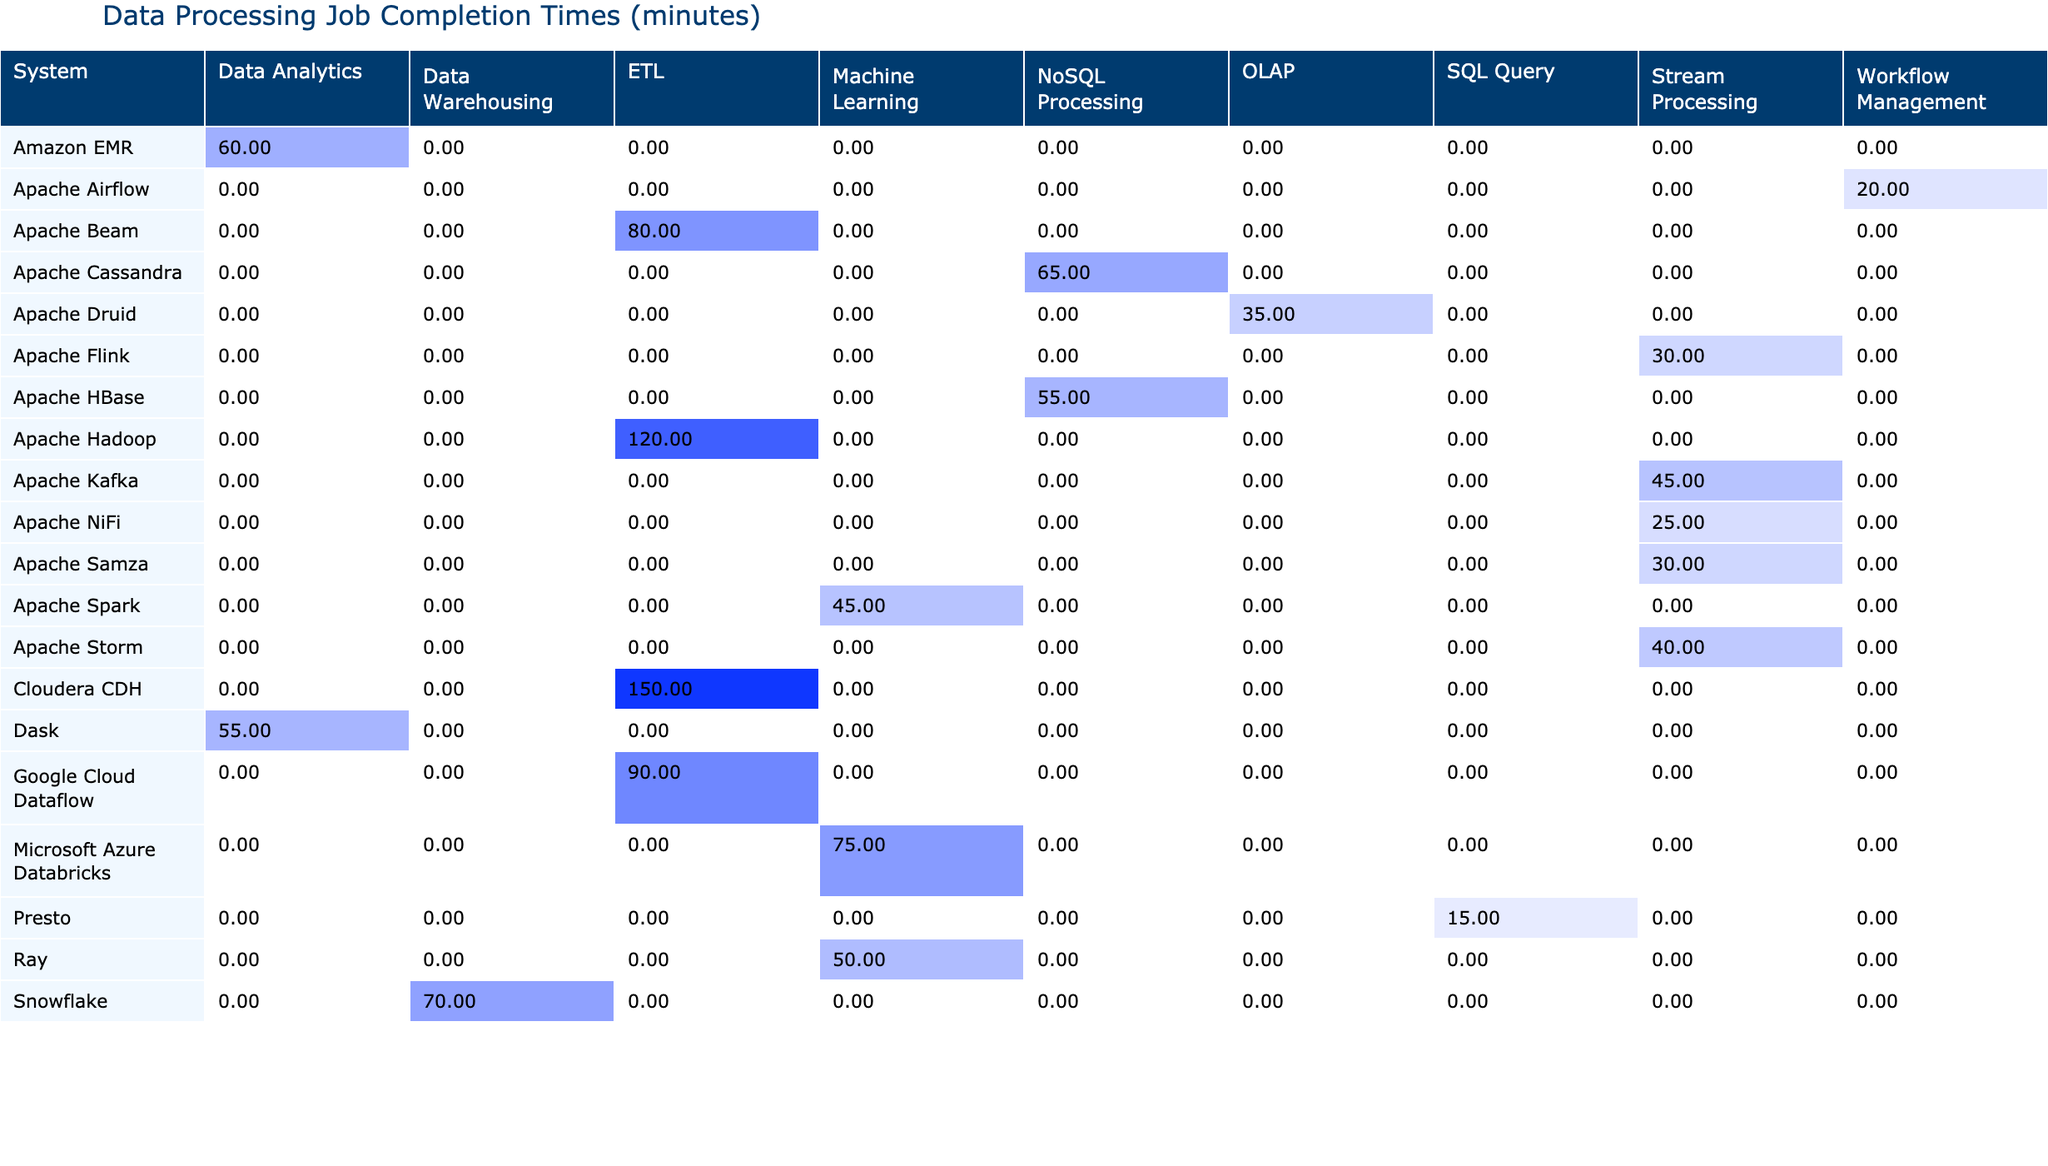What is the completion time for Apache Spark's Machine Learning job? The table lists completion times for specific job types under various systems. Looking under the column for Machine Learning and the row for Apache Spark, the value is 45.
Answer: 45 What is the average completion time for ETL jobs across all systems? To find the average completion time for ETL jobs, I need to identify the completion times for each ETL job: 120 (Apache Hadoop), 90 (Google Cloud Dataflow), 150 (Cloudera CDH), and 80 (Apache Beam). Adding these gives a total of 120 + 90 + 150 + 80 = 440. There are 4 ETL jobs, so the average is 440/4 = 110.
Answer: 110 Does Apache NiFi have a lower completion time than Apache Storm for Stream Processing jobs? By examining the table, Apache NiFi's completion time for Stream Processing is 25 minutes, while Apache Storm's is 40 minutes. Since 25 is less than 40, the answer is yes.
Answer: Yes Which system has the highest completion time for Data Analytics jobs? The table shows that Dask has a completion time of 55 minutes for Data Analytics, while Amazon EMR has 60 minutes. Comparing both, Amazon EMR has the highest completion time of the two systems.
Answer: 60 What is the total completion time for all Machine Learning jobs listed? For Machine Learning jobs, the completion times are: 45 (Apache Spark), 75 (Microsoft Azure Databricks), and 50 (Ray). Summing these values gives 45 + 75 + 50 = 170.
Answer: 170 Is the completion time for Presto's SQL Query job higher or lower than 20 minutes? The table indicates that Presto's completion time is 15 minutes. Since 15 is lower than 20, the answer is lower.
Answer: Lower What is the difference between the fastest and slowest completion times for Stream Processing jobs? The fastest completion time for Stream Processing is 25 (Apache NiFi), and the slowest is 40 (Apache Storm). The difference is calculated as 40 - 25 = 15.
Answer: 15 Which system demonstrated the most efficiency based on the lowest average completion time for similar job types? Analyzing the completion times across job types reveals that Apache Flink has the lowest time of 30 minutes for Stream Processing, while others have higher times across their respective job types. Thus, it can be concluded that Apache Flink demonstrated the most efficiency in its job type.
Answer: Apache Flink What are the completion times for NoSQL Processing jobs combined? The completion times for NoSQL Processing jobs are 65 (Apache Cassandra) and 55 (Apache HBase). Adding them together gives a total of 65 + 55 = 120.
Answer: 120 